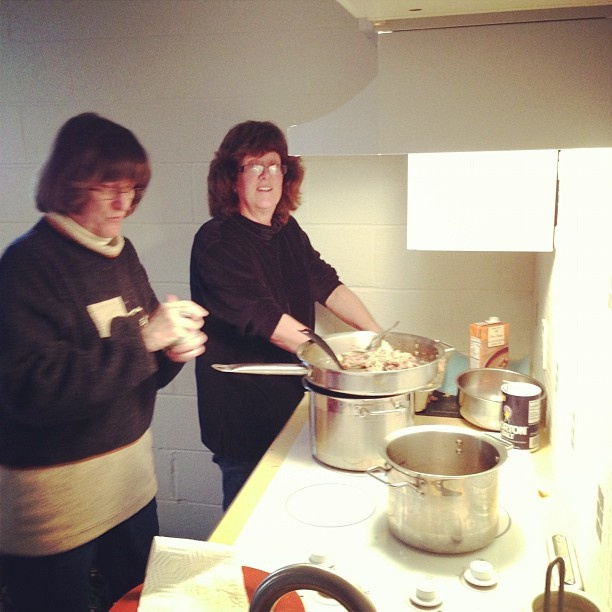Describe the objects in this image and their specific colors. I can see people in gray, black, tan, and brown tones, oven in gray, ivory, khaki, and tan tones, people in gray, black, maroon, tan, and brown tones, bowl in gray, tan, beige, and lightyellow tones, and bottle in gray, ivory, brown, and beige tones in this image. 